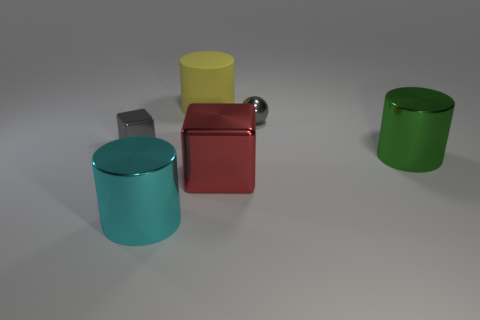Subtract all green cylinders. How many cylinders are left? 2 Subtract all blocks. How many objects are left? 4 Subtract 2 cubes. How many cubes are left? 0 Add 3 balls. How many objects exist? 9 Subtract all yellow cylinders. How many cylinders are left? 2 Subtract all brown cylinders. Subtract all blue spheres. How many cylinders are left? 3 Subtract all green cylinders. How many red cubes are left? 1 Subtract all red metal blocks. Subtract all cylinders. How many objects are left? 2 Add 2 big cyan metallic things. How many big cyan metallic things are left? 3 Add 5 brown metallic cubes. How many brown metallic cubes exist? 5 